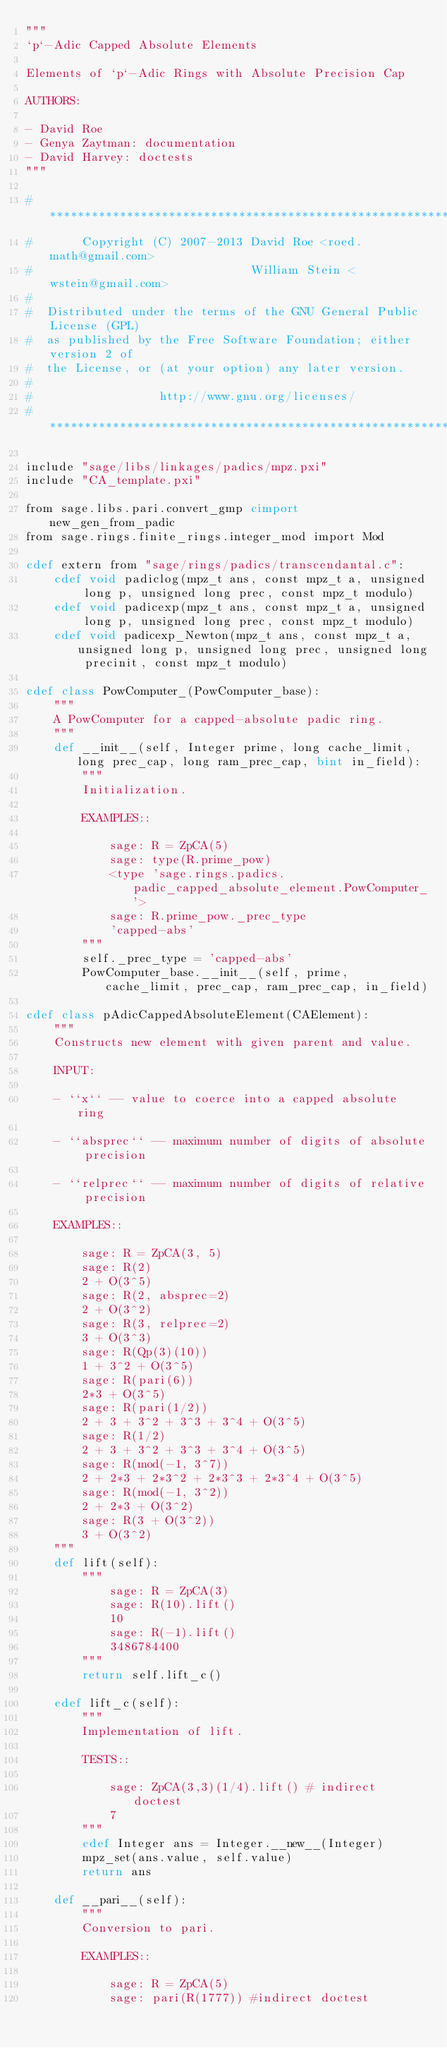Convert code to text. <code><loc_0><loc_0><loc_500><loc_500><_Cython_>"""
`p`-Adic Capped Absolute Elements

Elements of `p`-Adic Rings with Absolute Precision Cap

AUTHORS:

- David Roe
- Genya Zaytman: documentation
- David Harvey: doctests
"""

#*****************************************************************************
#       Copyright (C) 2007-2013 David Roe <roed.math@gmail.com>
#                               William Stein <wstein@gmail.com>
#
#  Distributed under the terms of the GNU General Public License (GPL)
#  as published by the Free Software Foundation; either version 2 of
#  the License, or (at your option) any later version.
#
#                  http://www.gnu.org/licenses/
#*****************************************************************************

include "sage/libs/linkages/padics/mpz.pxi"
include "CA_template.pxi"

from sage.libs.pari.convert_gmp cimport new_gen_from_padic
from sage.rings.finite_rings.integer_mod import Mod

cdef extern from "sage/rings/padics/transcendantal.c":
    cdef void padiclog(mpz_t ans, const mpz_t a, unsigned long p, unsigned long prec, const mpz_t modulo)
    cdef void padicexp(mpz_t ans, const mpz_t a, unsigned long p, unsigned long prec, const mpz_t modulo)
    cdef void padicexp_Newton(mpz_t ans, const mpz_t a, unsigned long p, unsigned long prec, unsigned long precinit, const mpz_t modulo)

cdef class PowComputer_(PowComputer_base):
    """
    A PowComputer for a capped-absolute padic ring.
    """
    def __init__(self, Integer prime, long cache_limit, long prec_cap, long ram_prec_cap, bint in_field):
        """
        Initialization.

        EXAMPLES::

            sage: R = ZpCA(5)
            sage: type(R.prime_pow)
            <type 'sage.rings.padics.padic_capped_absolute_element.PowComputer_'>
            sage: R.prime_pow._prec_type
            'capped-abs'
        """
        self._prec_type = 'capped-abs'
        PowComputer_base.__init__(self, prime, cache_limit, prec_cap, ram_prec_cap, in_field)

cdef class pAdicCappedAbsoluteElement(CAElement):
    """
    Constructs new element with given parent and value.

    INPUT:

    - ``x`` -- value to coerce into a capped absolute ring

    - ``absprec`` -- maximum number of digits of absolute precision

    - ``relprec`` -- maximum number of digits of relative precision

    EXAMPLES::

        sage: R = ZpCA(3, 5)
        sage: R(2)
        2 + O(3^5)
        sage: R(2, absprec=2)
        2 + O(3^2)
        sage: R(3, relprec=2)
        3 + O(3^3)
        sage: R(Qp(3)(10))
        1 + 3^2 + O(3^5)
        sage: R(pari(6))
        2*3 + O(3^5)
        sage: R(pari(1/2))
        2 + 3 + 3^2 + 3^3 + 3^4 + O(3^5)
        sage: R(1/2)
        2 + 3 + 3^2 + 3^3 + 3^4 + O(3^5)
        sage: R(mod(-1, 3^7))
        2 + 2*3 + 2*3^2 + 2*3^3 + 2*3^4 + O(3^5)
        sage: R(mod(-1, 3^2))
        2 + 2*3 + O(3^2)
        sage: R(3 + O(3^2))
        3 + O(3^2)
    """
    def lift(self):
        """
            sage: R = ZpCA(3)
            sage: R(10).lift()
            10
            sage: R(-1).lift()
            3486784400
        """
        return self.lift_c()

    cdef lift_c(self):
        """
        Implementation of lift.

        TESTS::

            sage: ZpCA(3,3)(1/4).lift() # indirect doctest
            7
        """
        cdef Integer ans = Integer.__new__(Integer)
        mpz_set(ans.value, self.value)
        return ans

    def __pari__(self):
        """
        Conversion to pari.

        EXAMPLES::

            sage: R = ZpCA(5)
            sage: pari(R(1777)) #indirect doctest</code> 